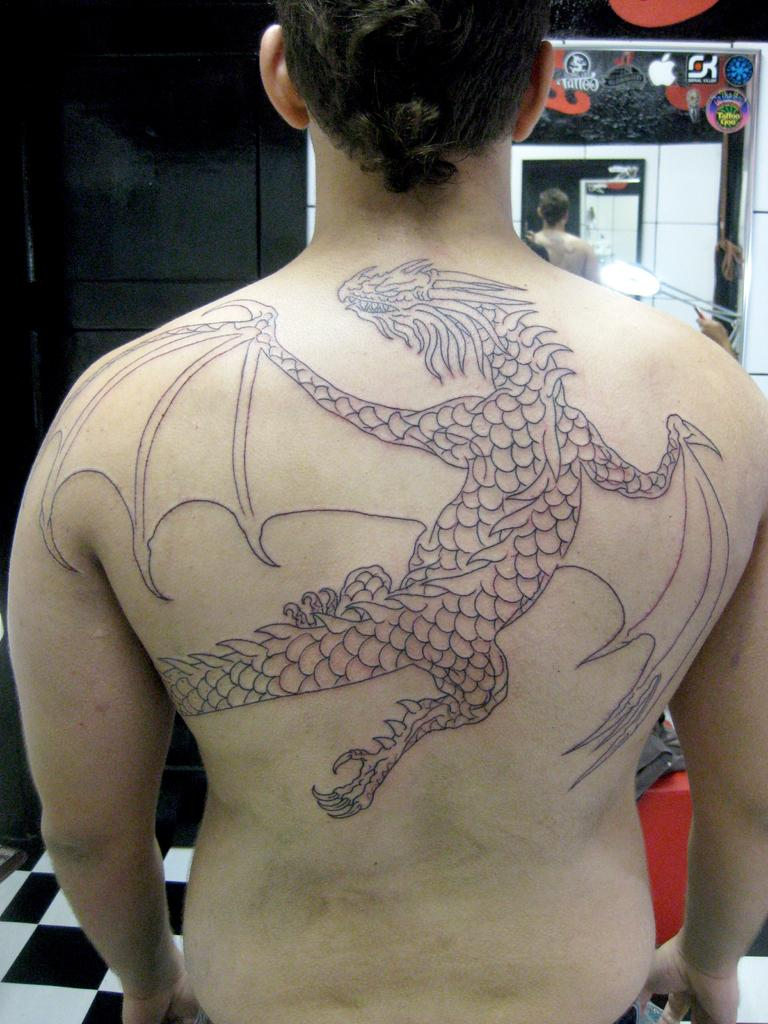What can be seen on the person in the image? There is a person with a tattoo in the image. What is visible in the background of the image? There is a door, a mirror, and other objects in the background of the image. Can you describe the setting of the image? The image may have been taken in a room, as suggested by the presence of a door and a mirror. What type of hate can be seen on the person's chin in the image? There is no hate or chin visible in the image; it features a person with a tattoo and various objects in the background. 